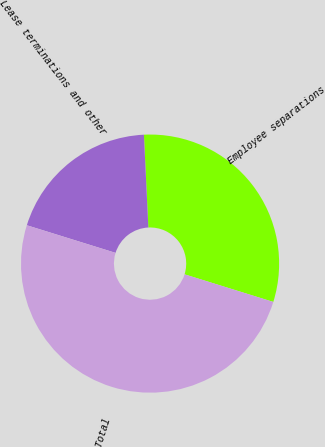Convert chart. <chart><loc_0><loc_0><loc_500><loc_500><pie_chart><fcel>Employee separations<fcel>Lease terminations and other<fcel>Total<nl><fcel>30.56%<fcel>19.44%<fcel>50.0%<nl></chart> 